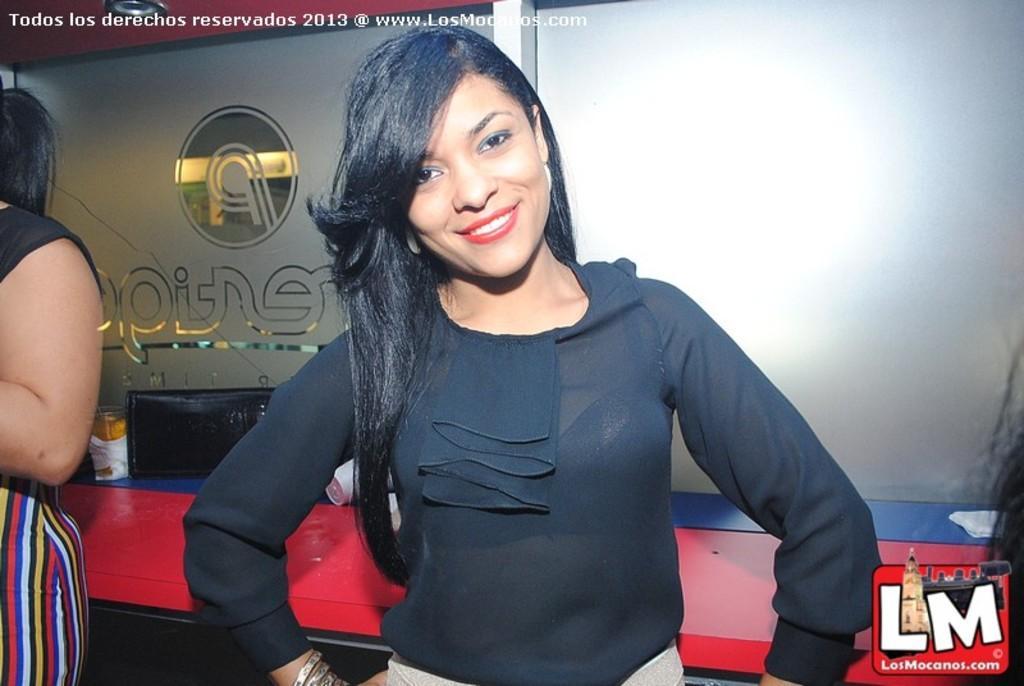Please provide a concise description of this image. In this image a lady wearing black top is standing. She is smiling. Here we can see another person. In the background there is wall. On the table there is monitor and few other things. 